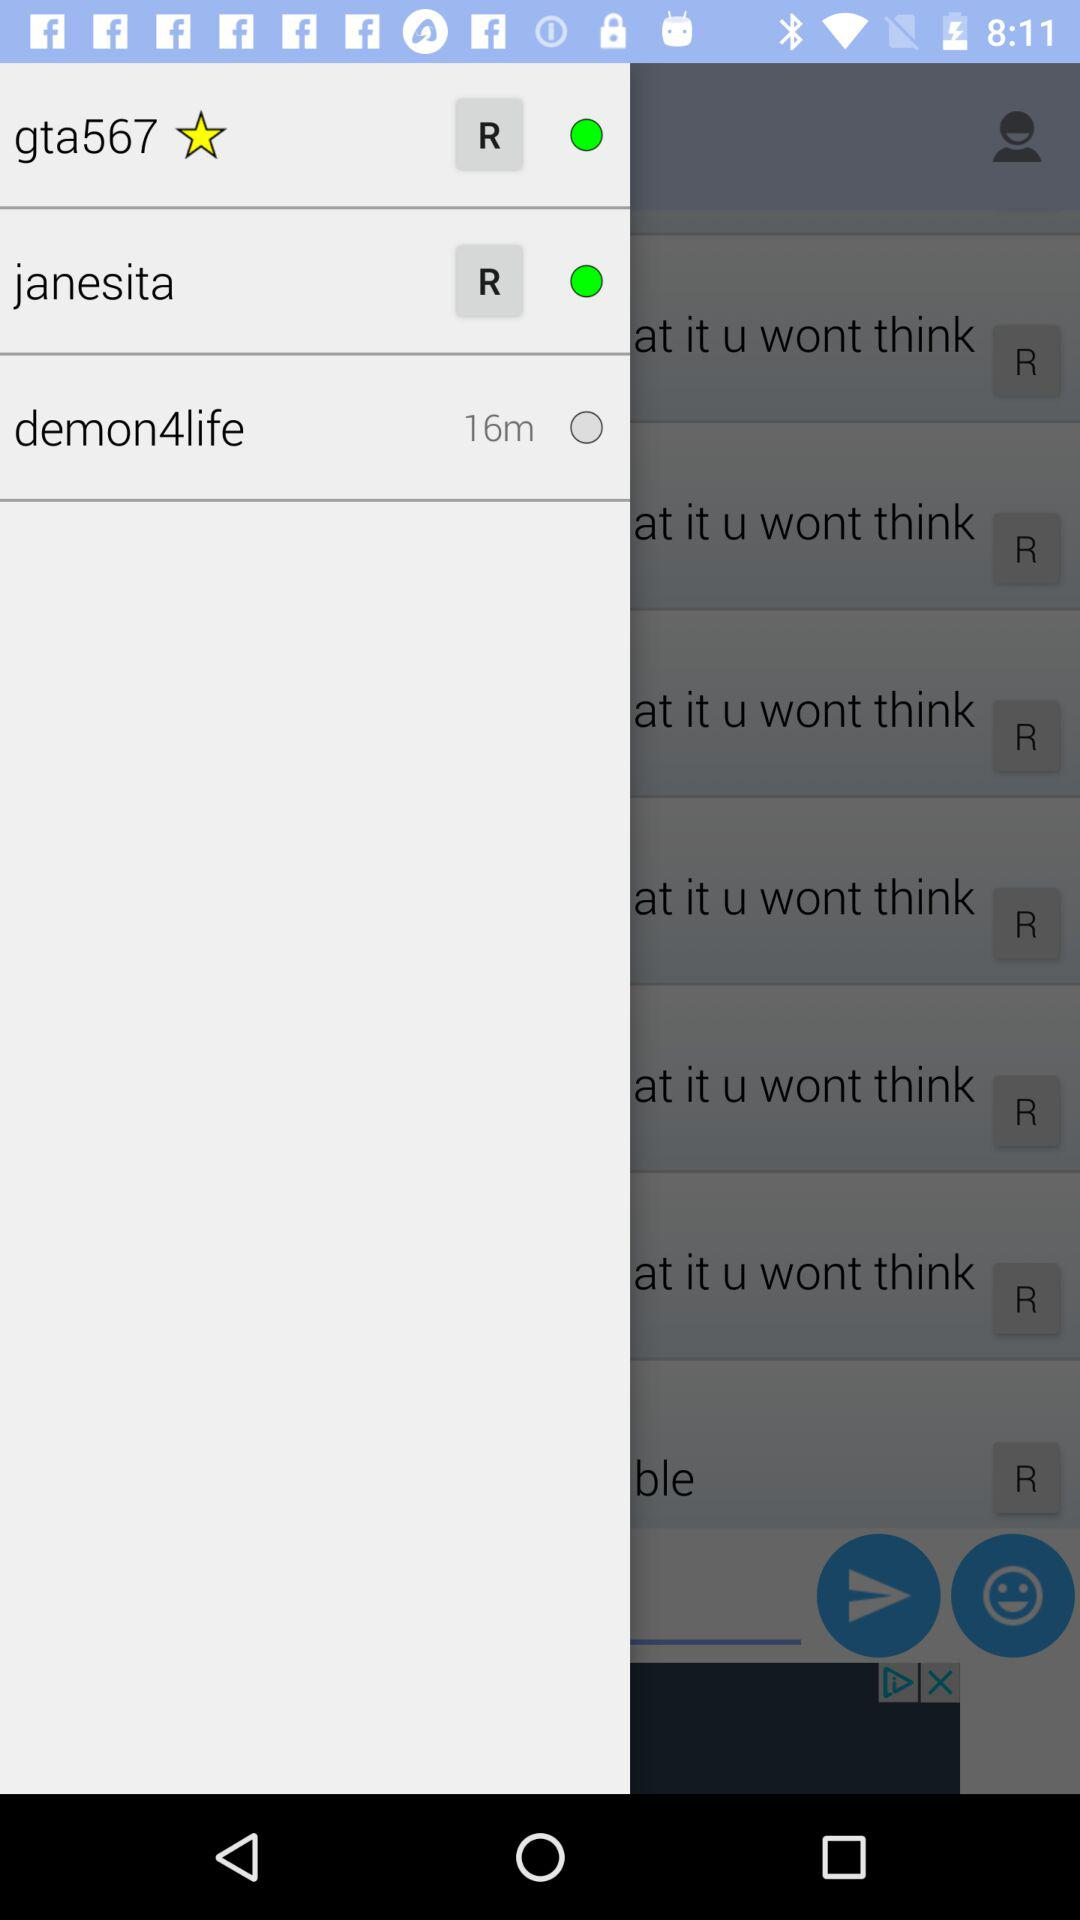Which option is selected? The selected option are "gta567" and "janestia". 